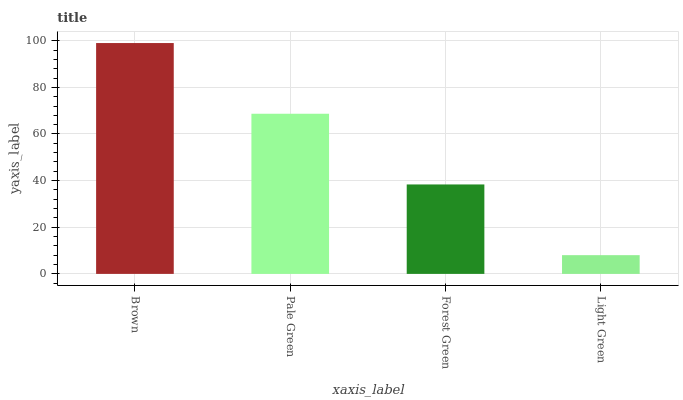Is Light Green the minimum?
Answer yes or no. Yes. Is Brown the maximum?
Answer yes or no. Yes. Is Pale Green the minimum?
Answer yes or no. No. Is Pale Green the maximum?
Answer yes or no. No. Is Brown greater than Pale Green?
Answer yes or no. Yes. Is Pale Green less than Brown?
Answer yes or no. Yes. Is Pale Green greater than Brown?
Answer yes or no. No. Is Brown less than Pale Green?
Answer yes or no. No. Is Pale Green the high median?
Answer yes or no. Yes. Is Forest Green the low median?
Answer yes or no. Yes. Is Brown the high median?
Answer yes or no. No. Is Pale Green the low median?
Answer yes or no. No. 